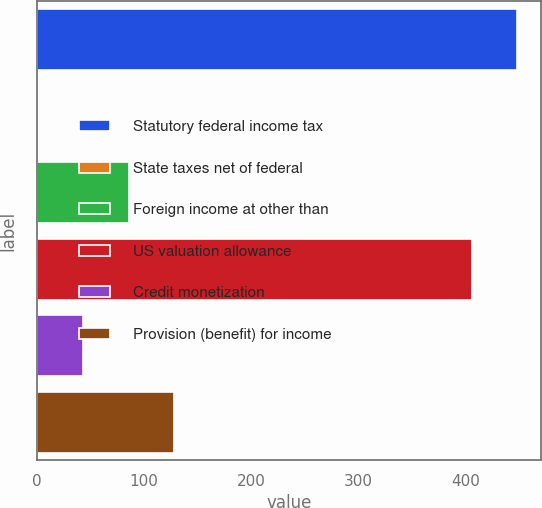<chart> <loc_0><loc_0><loc_500><loc_500><bar_chart><fcel>Statutory federal income tax<fcel>State taxes net of federal<fcel>Foreign income at other than<fcel>US valuation allowance<fcel>Credit monetization<fcel>Provision (benefit) for income<nl><fcel>448.5<fcel>1<fcel>86<fcel>406<fcel>43.5<fcel>128.5<nl></chart> 